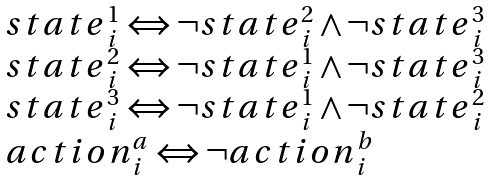<formula> <loc_0><loc_0><loc_500><loc_500>\begin{array} { l } { s t a t e } _ { i } ^ { 1 } \Leftrightarrow \neg { s t a t e } _ { i } ^ { 2 } \land \neg { s t a t e } _ { i } ^ { 3 } \\ { s t a t e } _ { i } ^ { 2 } \Leftrightarrow \neg { s t a t e } _ { i } ^ { 1 } \land \neg { s t a t e } _ { i } ^ { 3 } \\ { s t a t e } _ { i } ^ { 3 } \Leftrightarrow \neg { s t a t e } _ { i } ^ { 1 } \land \neg { s t a t e } _ { i } ^ { 2 } \\ { a c t i o n } _ { i } ^ { a } \Leftrightarrow \neg { a c t i o n } _ { i } ^ { b } \\ \end{array}</formula> 